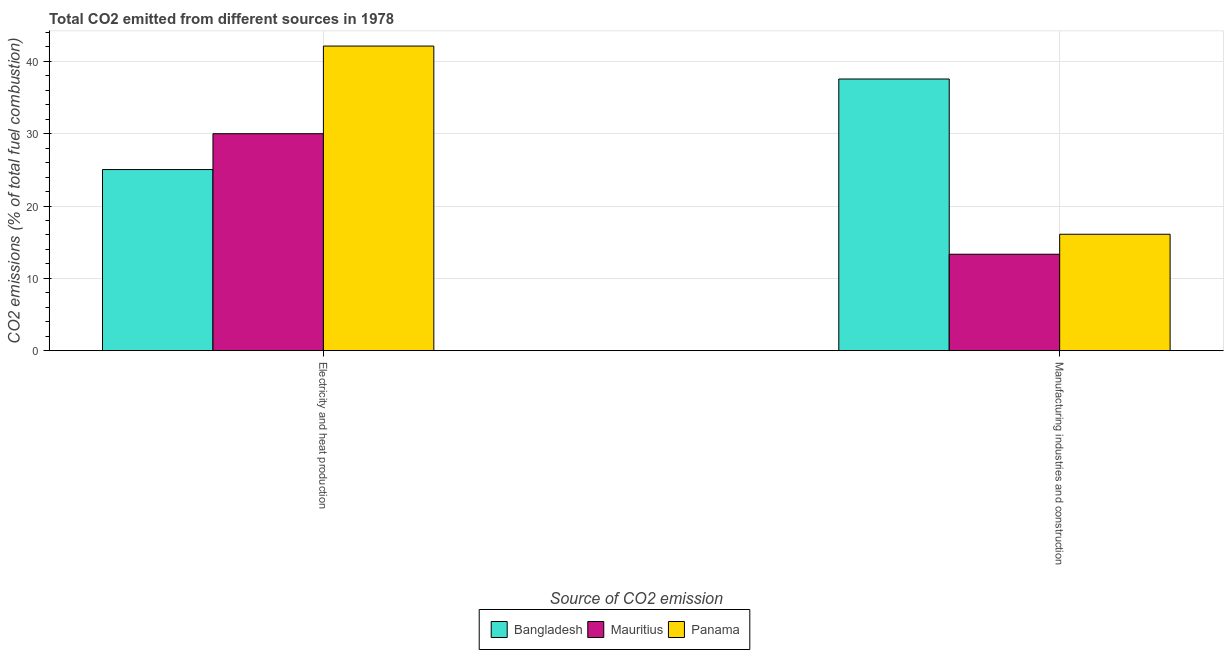How many different coloured bars are there?
Provide a short and direct response. 3. How many groups of bars are there?
Your answer should be very brief. 2. Are the number of bars per tick equal to the number of legend labels?
Your response must be concise. Yes. Are the number of bars on each tick of the X-axis equal?
Your response must be concise. Yes. How many bars are there on the 2nd tick from the left?
Offer a terse response. 3. How many bars are there on the 2nd tick from the right?
Offer a terse response. 3. What is the label of the 2nd group of bars from the left?
Make the answer very short. Manufacturing industries and construction. What is the co2 emissions due to manufacturing industries in Panama?
Keep it short and to the point. 16.1. Across all countries, what is the maximum co2 emissions due to manufacturing industries?
Make the answer very short. 37.57. Across all countries, what is the minimum co2 emissions due to manufacturing industries?
Give a very brief answer. 13.33. In which country was the co2 emissions due to manufacturing industries minimum?
Provide a short and direct response. Mauritius. What is the total co2 emissions due to manufacturing industries in the graph?
Provide a succinct answer. 67. What is the difference between the co2 emissions due to electricity and heat production in Mauritius and that in Bangladesh?
Offer a very short reply. 4.96. What is the difference between the co2 emissions due to manufacturing industries in Bangladesh and the co2 emissions due to electricity and heat production in Mauritius?
Ensure brevity in your answer.  7.57. What is the average co2 emissions due to manufacturing industries per country?
Make the answer very short. 22.33. What is the difference between the co2 emissions due to electricity and heat production and co2 emissions due to manufacturing industries in Panama?
Offer a very short reply. 26.03. In how many countries, is the co2 emissions due to manufacturing industries greater than 4 %?
Make the answer very short. 3. What is the ratio of the co2 emissions due to manufacturing industries in Bangladesh to that in Mauritius?
Your answer should be very brief. 2.82. Is the co2 emissions due to manufacturing industries in Panama less than that in Mauritius?
Provide a short and direct response. No. In how many countries, is the co2 emissions due to manufacturing industries greater than the average co2 emissions due to manufacturing industries taken over all countries?
Make the answer very short. 1. What does the 3rd bar from the left in Manufacturing industries and construction represents?
Your answer should be compact. Panama. What does the 1st bar from the right in Manufacturing industries and construction represents?
Your answer should be very brief. Panama. How many bars are there?
Ensure brevity in your answer.  6. What is the difference between two consecutive major ticks on the Y-axis?
Your response must be concise. 10. Are the values on the major ticks of Y-axis written in scientific E-notation?
Offer a very short reply. No. Does the graph contain grids?
Keep it short and to the point. Yes. How many legend labels are there?
Provide a short and direct response. 3. What is the title of the graph?
Ensure brevity in your answer.  Total CO2 emitted from different sources in 1978. What is the label or title of the X-axis?
Make the answer very short. Source of CO2 emission. What is the label or title of the Y-axis?
Make the answer very short. CO2 emissions (% of total fuel combustion). What is the CO2 emissions (% of total fuel combustion) of Bangladesh in Electricity and heat production?
Provide a succinct answer. 25.04. What is the CO2 emissions (% of total fuel combustion) of Mauritius in Electricity and heat production?
Provide a short and direct response. 30. What is the CO2 emissions (% of total fuel combustion) in Panama in Electricity and heat production?
Offer a terse response. 42.12. What is the CO2 emissions (% of total fuel combustion) in Bangladesh in Manufacturing industries and construction?
Ensure brevity in your answer.  37.57. What is the CO2 emissions (% of total fuel combustion) in Mauritius in Manufacturing industries and construction?
Your answer should be compact. 13.33. What is the CO2 emissions (% of total fuel combustion) of Panama in Manufacturing industries and construction?
Your answer should be compact. 16.1. Across all Source of CO2 emission, what is the maximum CO2 emissions (% of total fuel combustion) of Bangladesh?
Your response must be concise. 37.57. Across all Source of CO2 emission, what is the maximum CO2 emissions (% of total fuel combustion) of Mauritius?
Provide a succinct answer. 30. Across all Source of CO2 emission, what is the maximum CO2 emissions (% of total fuel combustion) in Panama?
Your response must be concise. 42.12. Across all Source of CO2 emission, what is the minimum CO2 emissions (% of total fuel combustion) in Bangladesh?
Your response must be concise. 25.04. Across all Source of CO2 emission, what is the minimum CO2 emissions (% of total fuel combustion) in Mauritius?
Provide a succinct answer. 13.33. Across all Source of CO2 emission, what is the minimum CO2 emissions (% of total fuel combustion) in Panama?
Ensure brevity in your answer.  16.1. What is the total CO2 emissions (% of total fuel combustion) in Bangladesh in the graph?
Your answer should be very brief. 62.61. What is the total CO2 emissions (% of total fuel combustion) in Mauritius in the graph?
Your response must be concise. 43.33. What is the total CO2 emissions (% of total fuel combustion) in Panama in the graph?
Offer a very short reply. 58.22. What is the difference between the CO2 emissions (% of total fuel combustion) in Bangladesh in Electricity and heat production and that in Manufacturing industries and construction?
Your answer should be very brief. -12.52. What is the difference between the CO2 emissions (% of total fuel combustion) of Mauritius in Electricity and heat production and that in Manufacturing industries and construction?
Provide a succinct answer. 16.67. What is the difference between the CO2 emissions (% of total fuel combustion) in Panama in Electricity and heat production and that in Manufacturing industries and construction?
Provide a succinct answer. 26.03. What is the difference between the CO2 emissions (% of total fuel combustion) of Bangladesh in Electricity and heat production and the CO2 emissions (% of total fuel combustion) of Mauritius in Manufacturing industries and construction?
Provide a short and direct response. 11.71. What is the difference between the CO2 emissions (% of total fuel combustion) of Bangladesh in Electricity and heat production and the CO2 emissions (% of total fuel combustion) of Panama in Manufacturing industries and construction?
Your response must be concise. 8.95. What is the difference between the CO2 emissions (% of total fuel combustion) of Mauritius in Electricity and heat production and the CO2 emissions (% of total fuel combustion) of Panama in Manufacturing industries and construction?
Your answer should be compact. 13.9. What is the average CO2 emissions (% of total fuel combustion) of Bangladesh per Source of CO2 emission?
Offer a terse response. 31.31. What is the average CO2 emissions (% of total fuel combustion) of Mauritius per Source of CO2 emission?
Provide a succinct answer. 21.67. What is the average CO2 emissions (% of total fuel combustion) in Panama per Source of CO2 emission?
Give a very brief answer. 29.11. What is the difference between the CO2 emissions (% of total fuel combustion) in Bangladesh and CO2 emissions (% of total fuel combustion) in Mauritius in Electricity and heat production?
Offer a very short reply. -4.96. What is the difference between the CO2 emissions (% of total fuel combustion) of Bangladesh and CO2 emissions (% of total fuel combustion) of Panama in Electricity and heat production?
Ensure brevity in your answer.  -17.08. What is the difference between the CO2 emissions (% of total fuel combustion) in Mauritius and CO2 emissions (% of total fuel combustion) in Panama in Electricity and heat production?
Offer a terse response. -12.12. What is the difference between the CO2 emissions (% of total fuel combustion) of Bangladesh and CO2 emissions (% of total fuel combustion) of Mauritius in Manufacturing industries and construction?
Keep it short and to the point. 24.23. What is the difference between the CO2 emissions (% of total fuel combustion) of Bangladesh and CO2 emissions (% of total fuel combustion) of Panama in Manufacturing industries and construction?
Make the answer very short. 21.47. What is the difference between the CO2 emissions (% of total fuel combustion) of Mauritius and CO2 emissions (% of total fuel combustion) of Panama in Manufacturing industries and construction?
Provide a succinct answer. -2.76. What is the ratio of the CO2 emissions (% of total fuel combustion) of Mauritius in Electricity and heat production to that in Manufacturing industries and construction?
Offer a very short reply. 2.25. What is the ratio of the CO2 emissions (% of total fuel combustion) of Panama in Electricity and heat production to that in Manufacturing industries and construction?
Provide a succinct answer. 2.62. What is the difference between the highest and the second highest CO2 emissions (% of total fuel combustion) of Bangladesh?
Give a very brief answer. 12.52. What is the difference between the highest and the second highest CO2 emissions (% of total fuel combustion) in Mauritius?
Provide a succinct answer. 16.67. What is the difference between the highest and the second highest CO2 emissions (% of total fuel combustion) in Panama?
Give a very brief answer. 26.03. What is the difference between the highest and the lowest CO2 emissions (% of total fuel combustion) of Bangladesh?
Keep it short and to the point. 12.52. What is the difference between the highest and the lowest CO2 emissions (% of total fuel combustion) in Mauritius?
Provide a succinct answer. 16.67. What is the difference between the highest and the lowest CO2 emissions (% of total fuel combustion) in Panama?
Offer a very short reply. 26.03. 